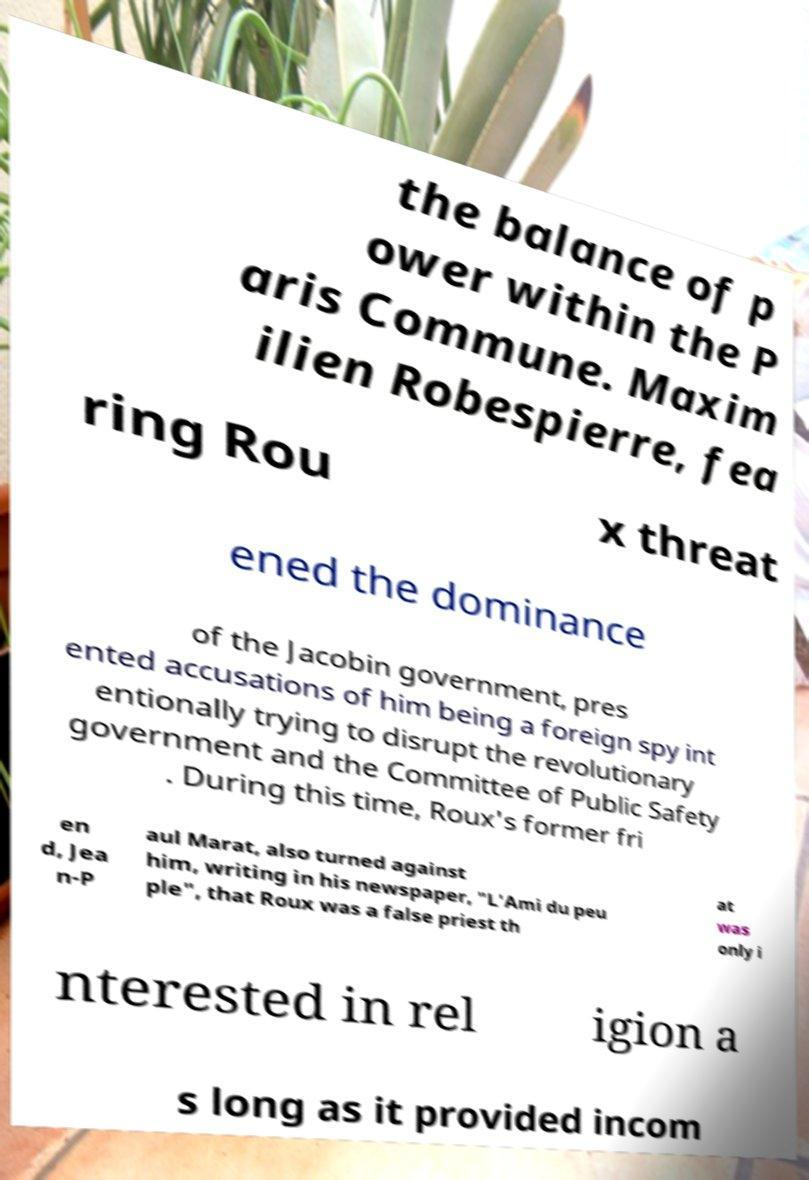Can you accurately transcribe the text from the provided image for me? the balance of p ower within the P aris Commune. Maxim ilien Robespierre, fea ring Rou x threat ened the dominance of the Jacobin government, pres ented accusations of him being a foreign spy int entionally trying to disrupt the revolutionary government and the Committee of Public Safety . During this time, Roux's former fri en d, Jea n-P aul Marat, also turned against him, writing in his newspaper, "L'Ami du peu ple", that Roux was a false priest th at was only i nterested in rel igion a s long as it provided incom 